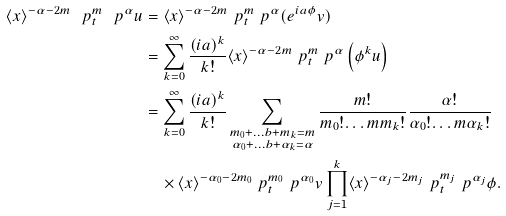<formula> <loc_0><loc_0><loc_500><loc_500>\langle { x } \rangle ^ { - \alpha - 2 m } \ p _ { t } ^ { m } \ p ^ { \alpha } u & = \langle { x } \rangle ^ { - \alpha - 2 m } \ p _ { t } ^ { m } \ p ^ { \alpha } ( e ^ { i a \phi } v ) \\ & = \sum _ { k = 0 } ^ { \infty } \frac { ( i a ) ^ { k } } { k ! } \langle { x } \rangle ^ { - \alpha - 2 m } \ p _ { t } ^ { m } \ p ^ { \alpha } \left ( \phi ^ { k } u \right ) \\ & = \sum _ { k = 0 } ^ { \infty } \frac { ( i a ) ^ { k } } { k ! } \sum _ { \substack { m _ { 0 } + \dots b + m _ { k } = m \\ \alpha _ { 0 } + \dots b + \alpha _ { k } = \alpha } } \frac { m ! } { m _ { 0 } ! { \dots m } m _ { k } ! } \frac { \alpha ! } { \alpha _ { 0 } ! { \dots m } \alpha _ { k } ! } \\ & \quad \times \langle { x } \rangle ^ { - \alpha _ { 0 } - 2 m _ { 0 } } \ p _ { t } ^ { m _ { 0 } } \ p ^ { \alpha _ { 0 } } v \prod _ { j = 1 } ^ { k } \langle { x } \rangle ^ { - \alpha _ { j } - 2 m _ { j } } \ p _ { t } ^ { m _ { j } } \ p ^ { \alpha _ { j } } \phi .</formula> 